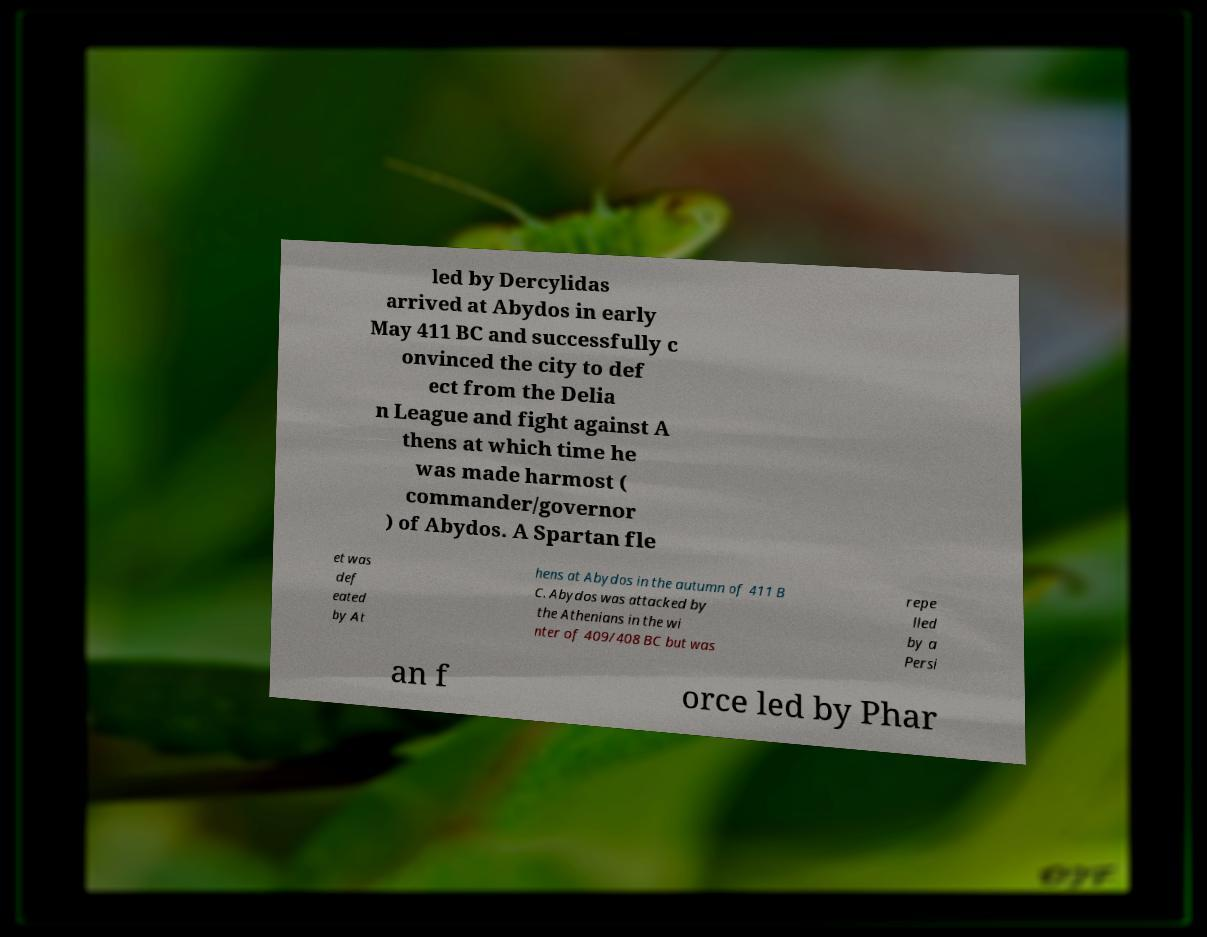What messages or text are displayed in this image? I need them in a readable, typed format. led by Dercylidas arrived at Abydos in early May 411 BC and successfully c onvinced the city to def ect from the Delia n League and fight against A thens at which time he was made harmost ( commander/governor ) of Abydos. A Spartan fle et was def eated by At hens at Abydos in the autumn of 411 B C. Abydos was attacked by the Athenians in the wi nter of 409/408 BC but was repe lled by a Persi an f orce led by Phar 